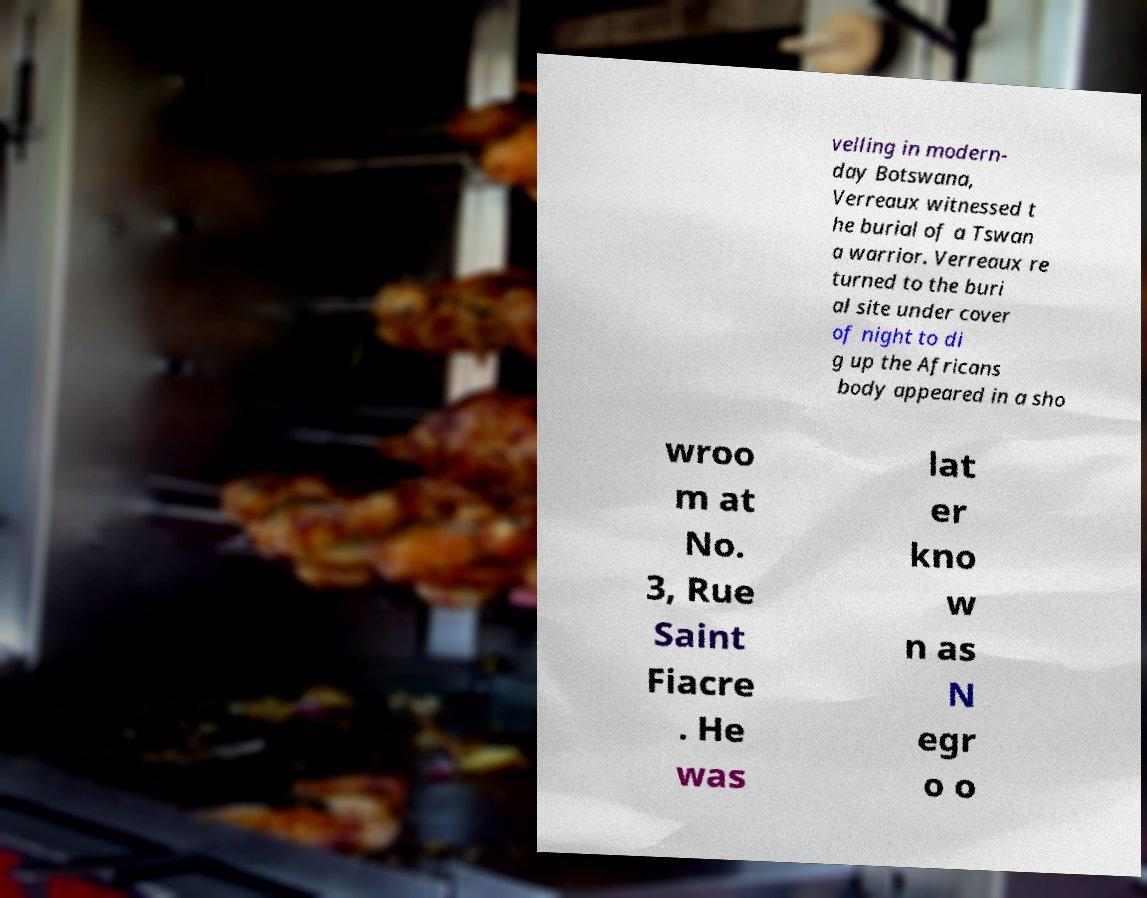For documentation purposes, I need the text within this image transcribed. Could you provide that? velling in modern- day Botswana, Verreaux witnessed t he burial of a Tswan a warrior. Verreaux re turned to the buri al site under cover of night to di g up the Africans body appeared in a sho wroo m at No. 3, Rue Saint Fiacre . He was lat er kno w n as N egr o o 